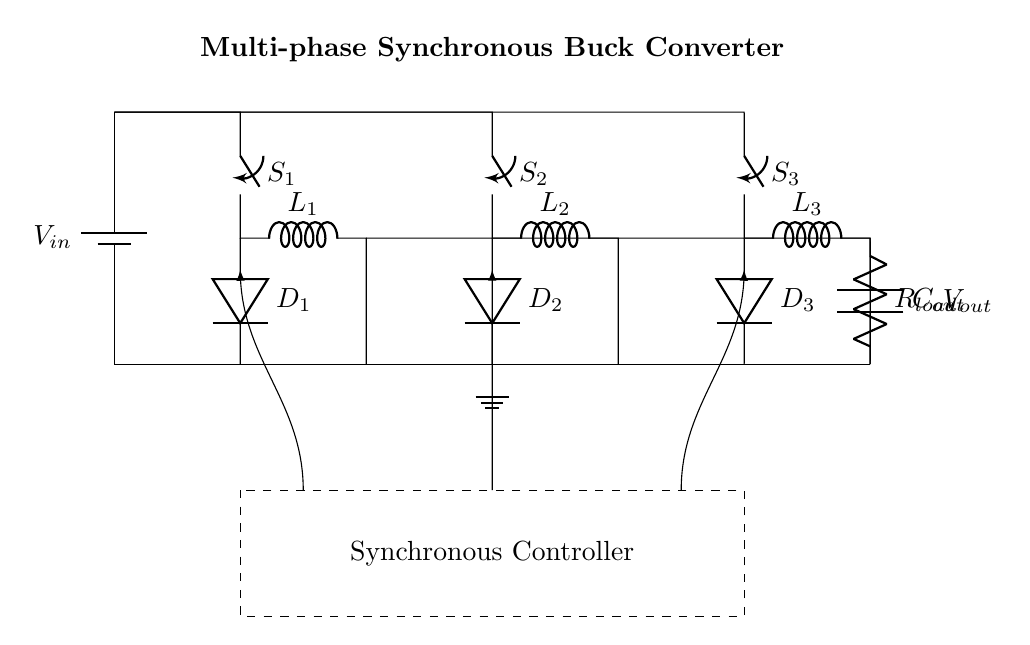What is the input voltage of the circuit? The input voltage is depicted as \(V_{in}\) in the diagram, shown coming from a battery.
Answer: \(V_{in}\) How many phases are in the buck converter? There are three phases visible in the circuit, each defined by a switch, inductor, and diode.
Answer: 3 What type of components are used for energy storage in this circuit? The energy storage components are inductors and an output capacitor. Inductors are labeled \(L_1\), \(L_2\), \(L_3\), and the capacitor is labeled \(C_{out}\).
Answer: Inductors and a capacitor What is the purpose of the synchronous controller in this circuit? The synchronous controller is responsible for managing the switching of the three phases to enable efficient operation, hence optimizing the output voltage.
Answer: Control switching Which component prevents reverse current in each phase? Diodes are used in each phase, labeled \(D_1\), \(D_2\), and \(D_3\), to prevent reverse current from flowing back.
Answer: Diodes What is the role of the load resistor? The load resistor, labeled \(R_{load}\), represents the load that the power supply will drive, consuming the output voltage generated by the converter.
Answer: Load resistor What happens when one of the switches fails in this circuit? If one of the switches fails, it would disrupt the current flow through that phase, potentially leading to reduced efficiency and output voltage ripple, depending on how the other phases compensate.
Answer: Disrupted current flow 